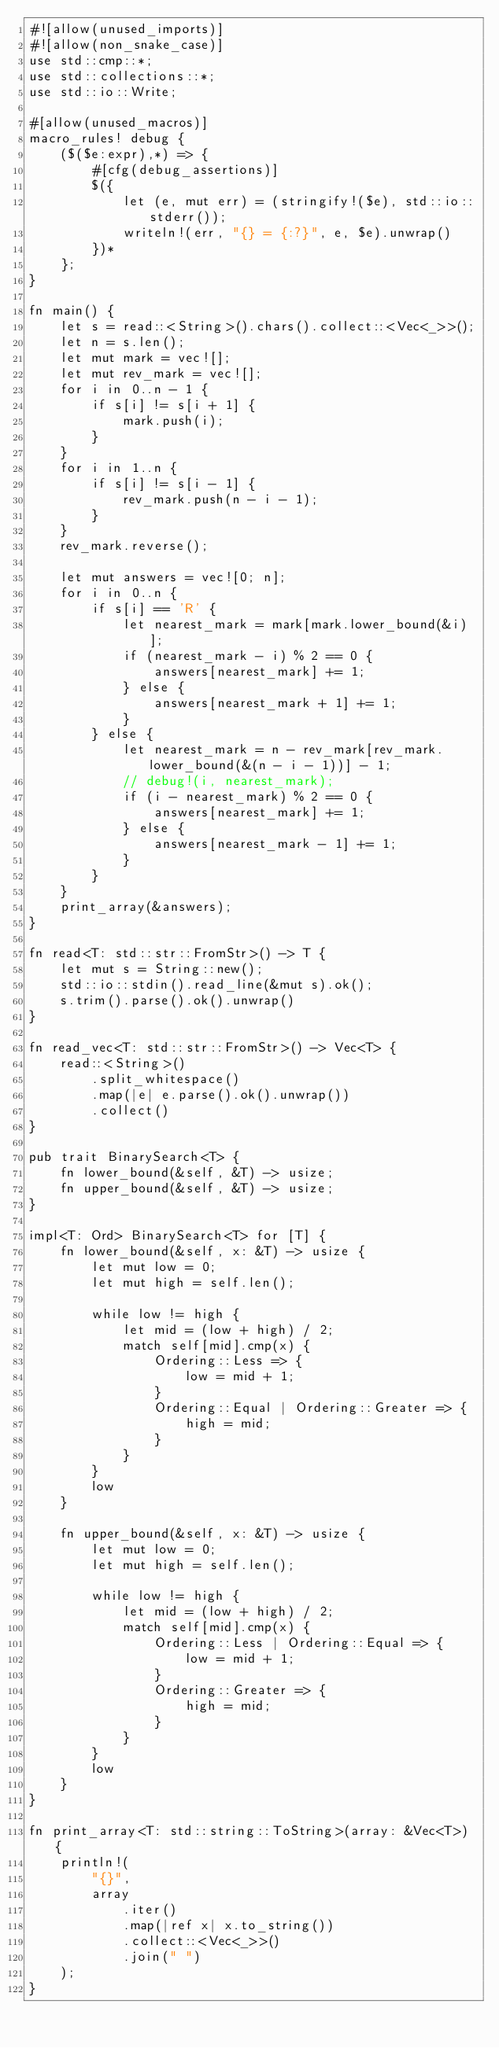Convert code to text. <code><loc_0><loc_0><loc_500><loc_500><_Rust_>#![allow(unused_imports)]
#![allow(non_snake_case)]
use std::cmp::*;
use std::collections::*;
use std::io::Write;

#[allow(unused_macros)]
macro_rules! debug {
    ($($e:expr),*) => {
        #[cfg(debug_assertions)]
        $({
            let (e, mut err) = (stringify!($e), std::io::stderr());
            writeln!(err, "{} = {:?}", e, $e).unwrap()
        })*
    };
}

fn main() {
    let s = read::<String>().chars().collect::<Vec<_>>();
    let n = s.len();
    let mut mark = vec![];
    let mut rev_mark = vec![];
    for i in 0..n - 1 {
        if s[i] != s[i + 1] {
            mark.push(i);
        }
    }
    for i in 1..n {
        if s[i] != s[i - 1] {
            rev_mark.push(n - i - 1);
        }
    }
    rev_mark.reverse();

    let mut answers = vec![0; n];
    for i in 0..n {
        if s[i] == 'R' {
            let nearest_mark = mark[mark.lower_bound(&i)];
            if (nearest_mark - i) % 2 == 0 {
                answers[nearest_mark] += 1;
            } else {
                answers[nearest_mark + 1] += 1;
            }
        } else {
            let nearest_mark = n - rev_mark[rev_mark.lower_bound(&(n - i - 1))] - 1;
            // debug!(i, nearest_mark);
            if (i - nearest_mark) % 2 == 0 {
                answers[nearest_mark] += 1;
            } else {
                answers[nearest_mark - 1] += 1;
            }
        }
    }
    print_array(&answers);
}

fn read<T: std::str::FromStr>() -> T {
    let mut s = String::new();
    std::io::stdin().read_line(&mut s).ok();
    s.trim().parse().ok().unwrap()
}

fn read_vec<T: std::str::FromStr>() -> Vec<T> {
    read::<String>()
        .split_whitespace()
        .map(|e| e.parse().ok().unwrap())
        .collect()
}

pub trait BinarySearch<T> {
    fn lower_bound(&self, &T) -> usize;
    fn upper_bound(&self, &T) -> usize;
}

impl<T: Ord> BinarySearch<T> for [T] {
    fn lower_bound(&self, x: &T) -> usize {
        let mut low = 0;
        let mut high = self.len();

        while low != high {
            let mid = (low + high) / 2;
            match self[mid].cmp(x) {
                Ordering::Less => {
                    low = mid + 1;
                }
                Ordering::Equal | Ordering::Greater => {
                    high = mid;
                }
            }
        }
        low
    }

    fn upper_bound(&self, x: &T) -> usize {
        let mut low = 0;
        let mut high = self.len();

        while low != high {
            let mid = (low + high) / 2;
            match self[mid].cmp(x) {
                Ordering::Less | Ordering::Equal => {
                    low = mid + 1;
                }
                Ordering::Greater => {
                    high = mid;
                }
            }
        }
        low
    }
}

fn print_array<T: std::string::ToString>(array: &Vec<T>) {
    println!(
        "{}",
        array
            .iter()
            .map(|ref x| x.to_string())
            .collect::<Vec<_>>()
            .join(" ")
    );
}
</code> 